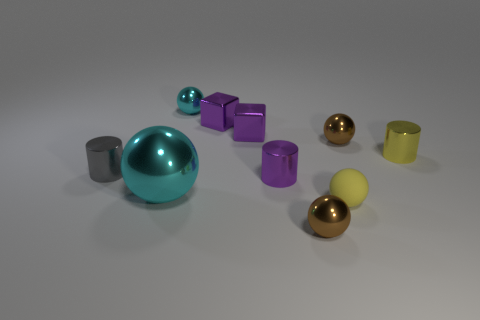What number of objects are big cyan things or small yellow metallic objects?
Your response must be concise. 2. How many large cyan objects are the same material as the big ball?
Keep it short and to the point. 0. There is another cyan metallic thing that is the same shape as the large cyan metallic object; what is its size?
Your response must be concise. Small. Are there any cyan metal things in front of the tiny matte ball?
Provide a short and direct response. No. What is the small cyan object made of?
Your answer should be compact. Metal. There is a metallic cylinder to the left of the small cyan shiny ball; is it the same color as the large sphere?
Provide a short and direct response. No. Are there any other things that are the same shape as the tiny cyan object?
Provide a short and direct response. Yes. What is the color of the big object that is the same shape as the tiny rubber object?
Offer a terse response. Cyan. There is a small brown thing that is in front of the tiny purple cylinder; what material is it?
Ensure brevity in your answer.  Metal. The large metallic object has what color?
Your response must be concise. Cyan. 